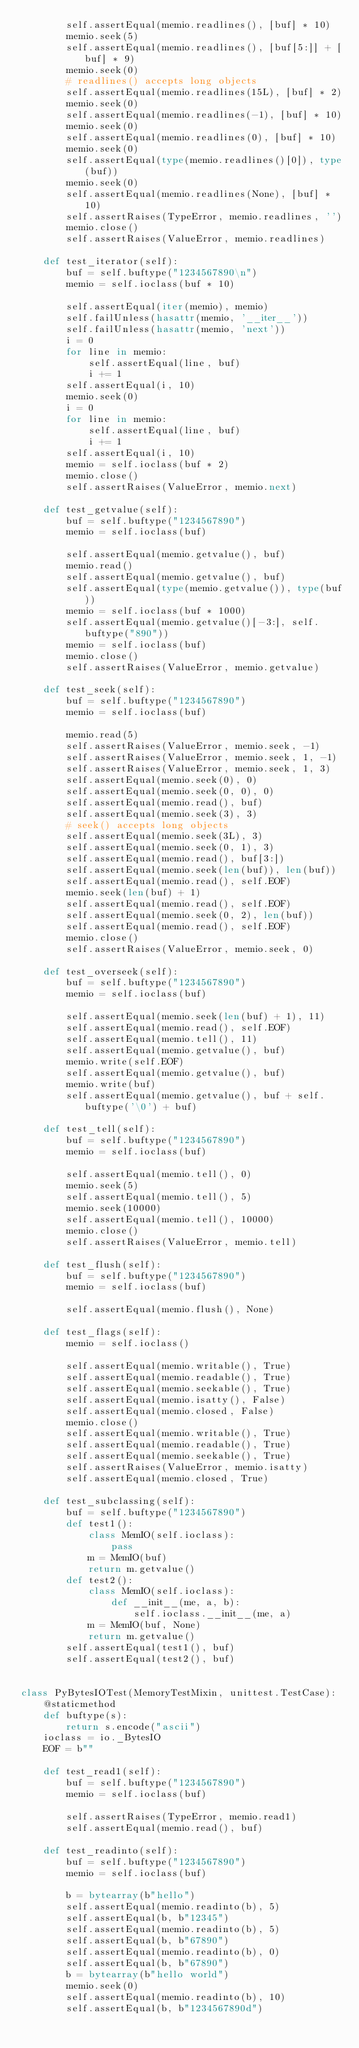Convert code to text. <code><loc_0><loc_0><loc_500><loc_500><_Python_>        self.assertEqual(memio.readlines(), [buf] * 10)
        memio.seek(5)
        self.assertEqual(memio.readlines(), [buf[5:]] + [buf] * 9)
        memio.seek(0)
        # readlines() accepts long objects
        self.assertEqual(memio.readlines(15L), [buf] * 2)
        memio.seek(0)
        self.assertEqual(memio.readlines(-1), [buf] * 10)
        memio.seek(0)
        self.assertEqual(memio.readlines(0), [buf] * 10)
        memio.seek(0)
        self.assertEqual(type(memio.readlines()[0]), type(buf))
        memio.seek(0)
        self.assertEqual(memio.readlines(None), [buf] * 10)
        self.assertRaises(TypeError, memio.readlines, '')
        memio.close()
        self.assertRaises(ValueError, memio.readlines)

    def test_iterator(self):
        buf = self.buftype("1234567890\n")
        memio = self.ioclass(buf * 10)

        self.assertEqual(iter(memio), memio)
        self.failUnless(hasattr(memio, '__iter__'))
        self.failUnless(hasattr(memio, 'next'))
        i = 0
        for line in memio:
            self.assertEqual(line, buf)
            i += 1
        self.assertEqual(i, 10)
        memio.seek(0)
        i = 0
        for line in memio:
            self.assertEqual(line, buf)
            i += 1
        self.assertEqual(i, 10)
        memio = self.ioclass(buf * 2)
        memio.close()
        self.assertRaises(ValueError, memio.next)

    def test_getvalue(self):
        buf = self.buftype("1234567890")
        memio = self.ioclass(buf)

        self.assertEqual(memio.getvalue(), buf)
        memio.read()
        self.assertEqual(memio.getvalue(), buf)
        self.assertEqual(type(memio.getvalue()), type(buf))
        memio = self.ioclass(buf * 1000)
        self.assertEqual(memio.getvalue()[-3:], self.buftype("890"))
        memio = self.ioclass(buf)
        memio.close()
        self.assertRaises(ValueError, memio.getvalue)

    def test_seek(self):
        buf = self.buftype("1234567890")
        memio = self.ioclass(buf)

        memio.read(5)
        self.assertRaises(ValueError, memio.seek, -1)
        self.assertRaises(ValueError, memio.seek, 1, -1)
        self.assertRaises(ValueError, memio.seek, 1, 3)
        self.assertEqual(memio.seek(0), 0)
        self.assertEqual(memio.seek(0, 0), 0)
        self.assertEqual(memio.read(), buf)
        self.assertEqual(memio.seek(3), 3)
        # seek() accepts long objects
        self.assertEqual(memio.seek(3L), 3)
        self.assertEqual(memio.seek(0, 1), 3)
        self.assertEqual(memio.read(), buf[3:])
        self.assertEqual(memio.seek(len(buf)), len(buf))
        self.assertEqual(memio.read(), self.EOF)
        memio.seek(len(buf) + 1)
        self.assertEqual(memio.read(), self.EOF)
        self.assertEqual(memio.seek(0, 2), len(buf))
        self.assertEqual(memio.read(), self.EOF)
        memio.close()
        self.assertRaises(ValueError, memio.seek, 0)

    def test_overseek(self):
        buf = self.buftype("1234567890")
        memio = self.ioclass(buf)

        self.assertEqual(memio.seek(len(buf) + 1), 11)
        self.assertEqual(memio.read(), self.EOF)
        self.assertEqual(memio.tell(), 11)
        self.assertEqual(memio.getvalue(), buf)
        memio.write(self.EOF)
        self.assertEqual(memio.getvalue(), buf)
        memio.write(buf)
        self.assertEqual(memio.getvalue(), buf + self.buftype('\0') + buf)

    def test_tell(self):
        buf = self.buftype("1234567890")
        memio = self.ioclass(buf)

        self.assertEqual(memio.tell(), 0)
        memio.seek(5)
        self.assertEqual(memio.tell(), 5)
        memio.seek(10000)
        self.assertEqual(memio.tell(), 10000)
        memio.close()
        self.assertRaises(ValueError, memio.tell)

    def test_flush(self):
        buf = self.buftype("1234567890")
        memio = self.ioclass(buf)

        self.assertEqual(memio.flush(), None)

    def test_flags(self):
        memio = self.ioclass()

        self.assertEqual(memio.writable(), True)
        self.assertEqual(memio.readable(), True)
        self.assertEqual(memio.seekable(), True)
        self.assertEqual(memio.isatty(), False)
        self.assertEqual(memio.closed, False)
        memio.close()
        self.assertEqual(memio.writable(), True)
        self.assertEqual(memio.readable(), True)
        self.assertEqual(memio.seekable(), True)
        self.assertRaises(ValueError, memio.isatty)
        self.assertEqual(memio.closed, True)

    def test_subclassing(self):
        buf = self.buftype("1234567890")
        def test1():
            class MemIO(self.ioclass):
                pass
            m = MemIO(buf)
            return m.getvalue()
        def test2():
            class MemIO(self.ioclass):
                def __init__(me, a, b):
                    self.ioclass.__init__(me, a)
            m = MemIO(buf, None)
            return m.getvalue()
        self.assertEqual(test1(), buf)
        self.assertEqual(test2(), buf)


class PyBytesIOTest(MemoryTestMixin, unittest.TestCase):
    @staticmethod
    def buftype(s):
        return s.encode("ascii")
    ioclass = io._BytesIO
    EOF = b""

    def test_read1(self):
        buf = self.buftype("1234567890")
        memio = self.ioclass(buf)

        self.assertRaises(TypeError, memio.read1)
        self.assertEqual(memio.read(), buf)

    def test_readinto(self):
        buf = self.buftype("1234567890")
        memio = self.ioclass(buf)

        b = bytearray(b"hello")
        self.assertEqual(memio.readinto(b), 5)
        self.assertEqual(b, b"12345")
        self.assertEqual(memio.readinto(b), 5)
        self.assertEqual(b, b"67890")
        self.assertEqual(memio.readinto(b), 0)
        self.assertEqual(b, b"67890")
        b = bytearray(b"hello world")
        memio.seek(0)
        self.assertEqual(memio.readinto(b), 10)
        self.assertEqual(b, b"1234567890d")</code> 